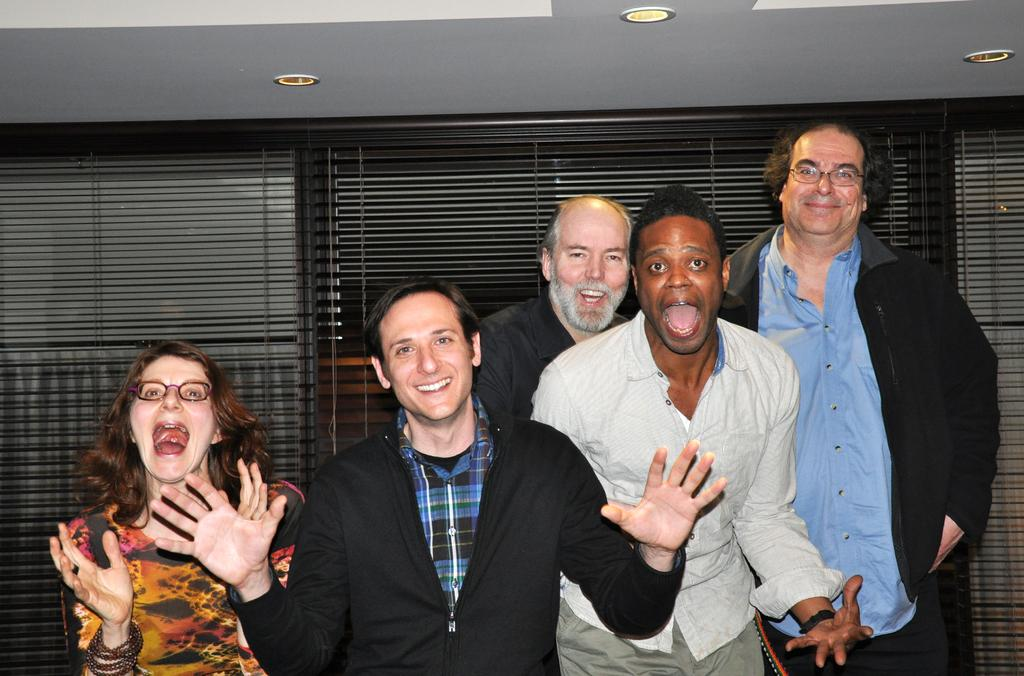What are the people in the image doing? The people in the image are standing and smiling. What can be seen beneath the people's feet in the image? There is a floor visible in the image. What can be seen in the background of the image? There are grills and electric lights on the roof in the background of the image. What type of corn is being used to play a musical instrument in the image? There is no corn or musical instrument present in the image. 